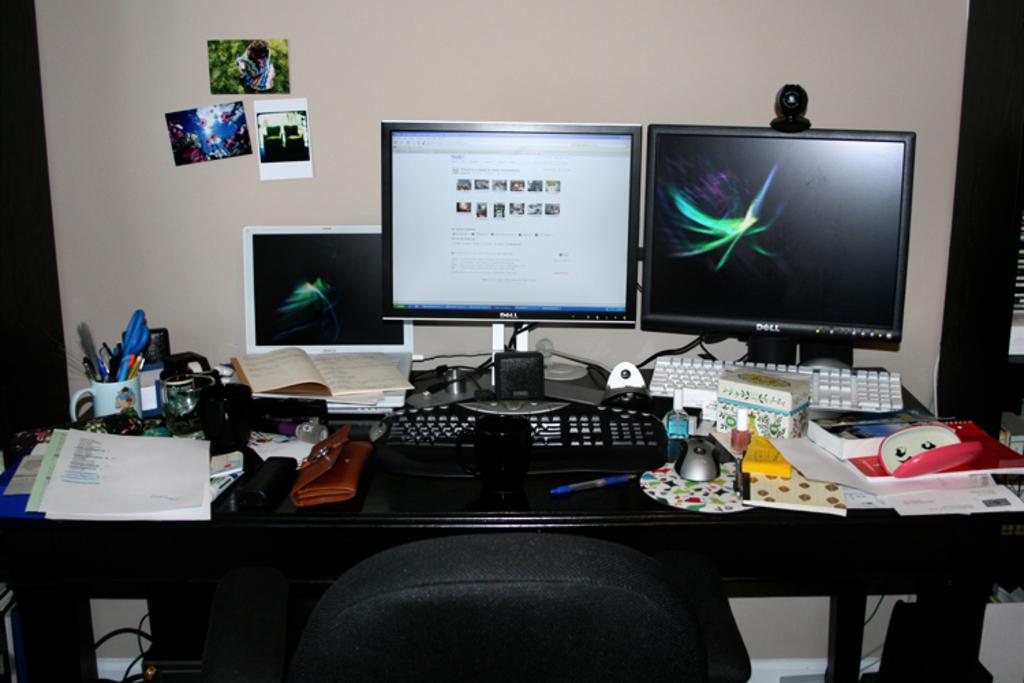Describe this image in one or two sentences. In this picture we can see a chair and also we can see paper, cup, pens, monitor, key board, mouse and some boxes on the table. 